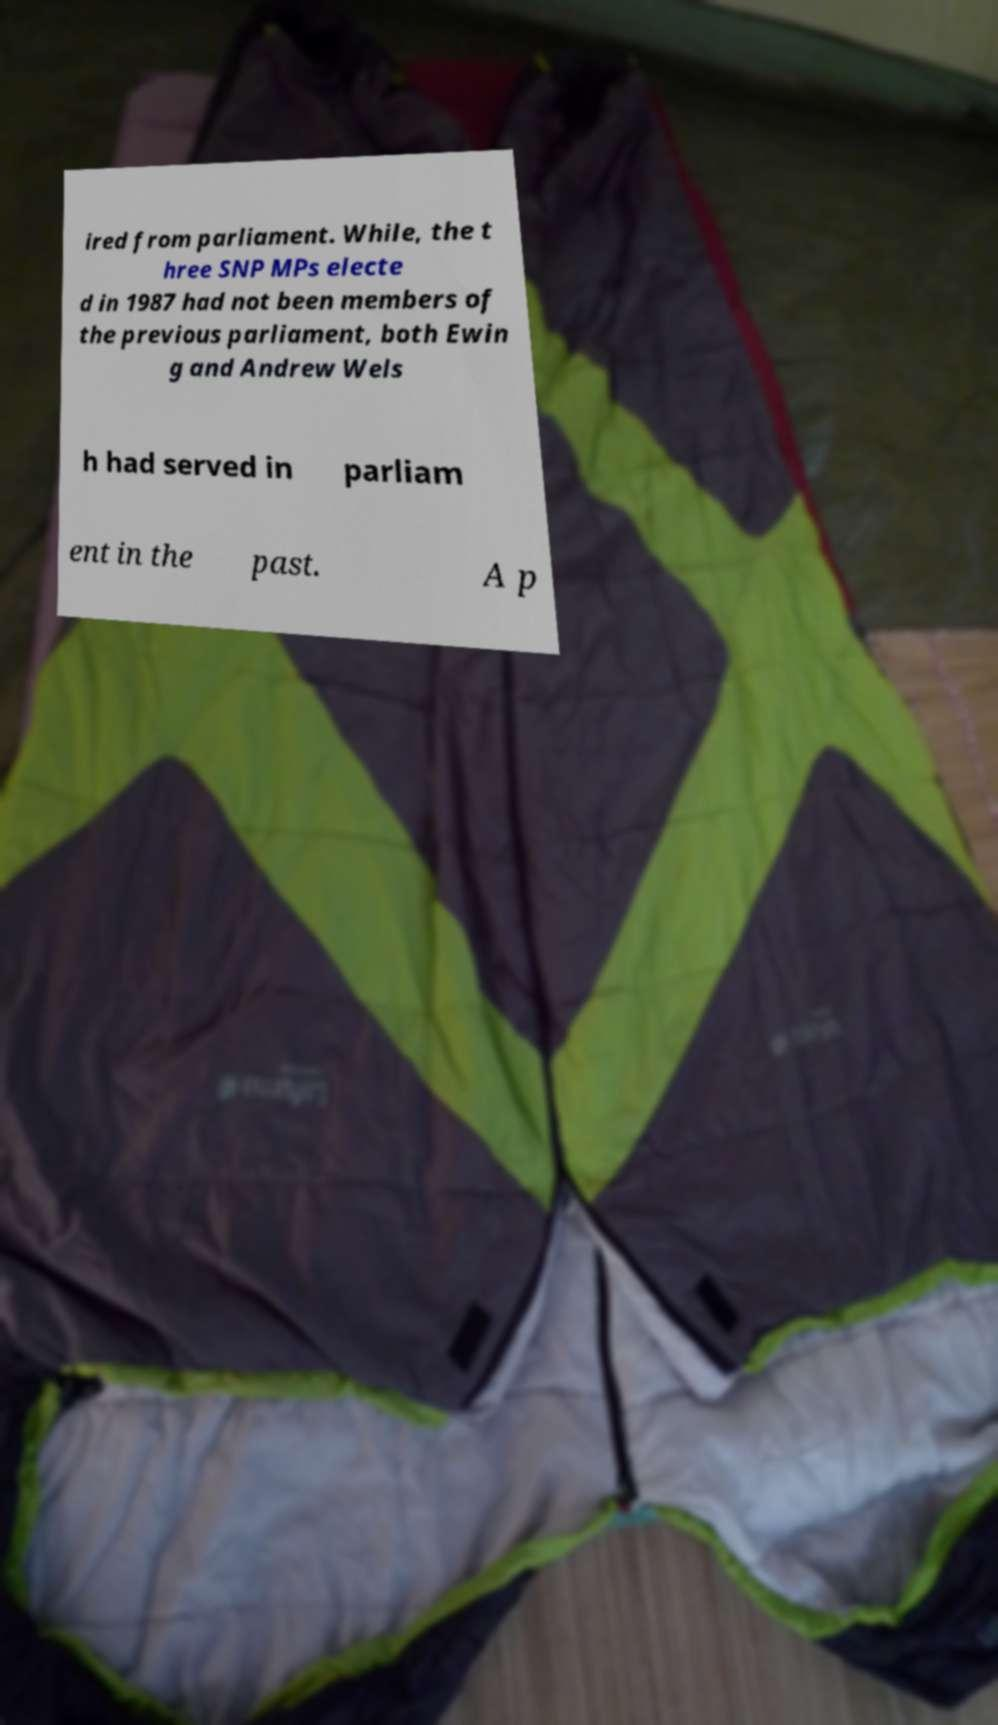There's text embedded in this image that I need extracted. Can you transcribe it verbatim? ired from parliament. While, the t hree SNP MPs electe d in 1987 had not been members of the previous parliament, both Ewin g and Andrew Wels h had served in parliam ent in the past. A p 